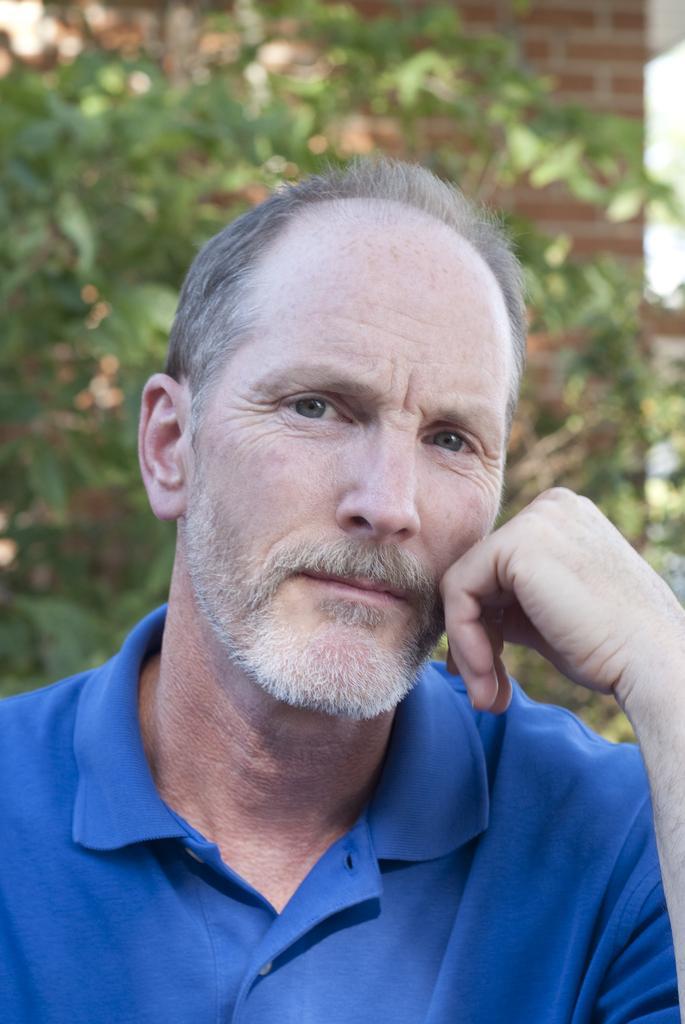Please provide a concise description of this image. In this image I can see a person. In the background, I can see the trees and the wall. 